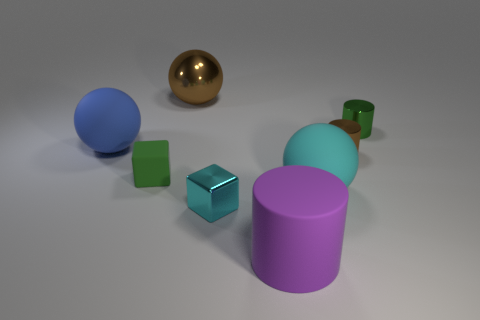How big is the matte thing that is left of the green object left of the cyan cube?
Your answer should be compact. Large. What number of large rubber spheres are the same color as the metallic block?
Give a very brief answer. 1. How many tiny brown cylinders are made of the same material as the large purple object?
Provide a succinct answer. 0. What number of objects are large purple objects or small objects right of the green rubber cube?
Offer a very short reply. 4. There is a matte sphere that is right of the matte object in front of the rubber ball that is on the right side of the tiny metallic cube; what is its color?
Make the answer very short. Cyan. There is a rubber ball on the right side of the tiny green matte thing; what is its size?
Give a very brief answer. Large. How many tiny things are either purple rubber objects or brown rubber cylinders?
Provide a succinct answer. 0. The rubber object that is both to the left of the brown sphere and in front of the small brown metal thing is what color?
Your response must be concise. Green. Are there any big green matte objects of the same shape as the large brown thing?
Your response must be concise. No. What is the brown cylinder made of?
Your answer should be very brief. Metal. 